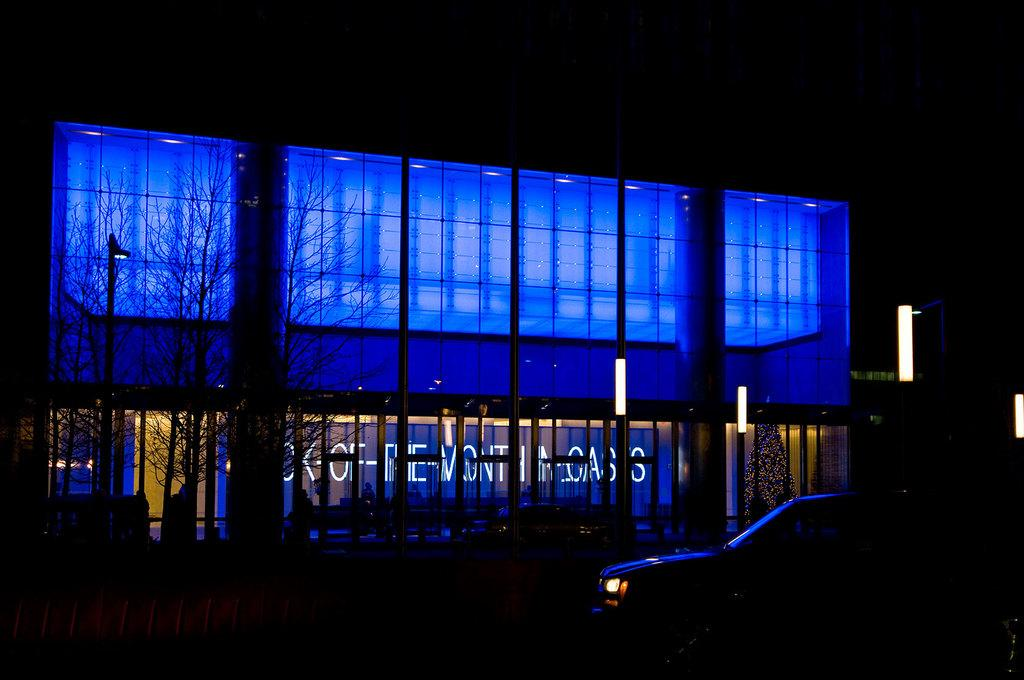What is the main subject in the center of the image? There is a building and a car in the center of the image. What else can be seen in the center of the image besides the building and car? There are lights in the center of the image. What type of vegetation is on the left side of the image? There are trees on the left side of the image. What is the color of the background in the image? The background of the image is black in color. Where is the bucket located in the image? There is no bucket present in the image. What type of bun is being served in the image? There is no bun present in the image. 